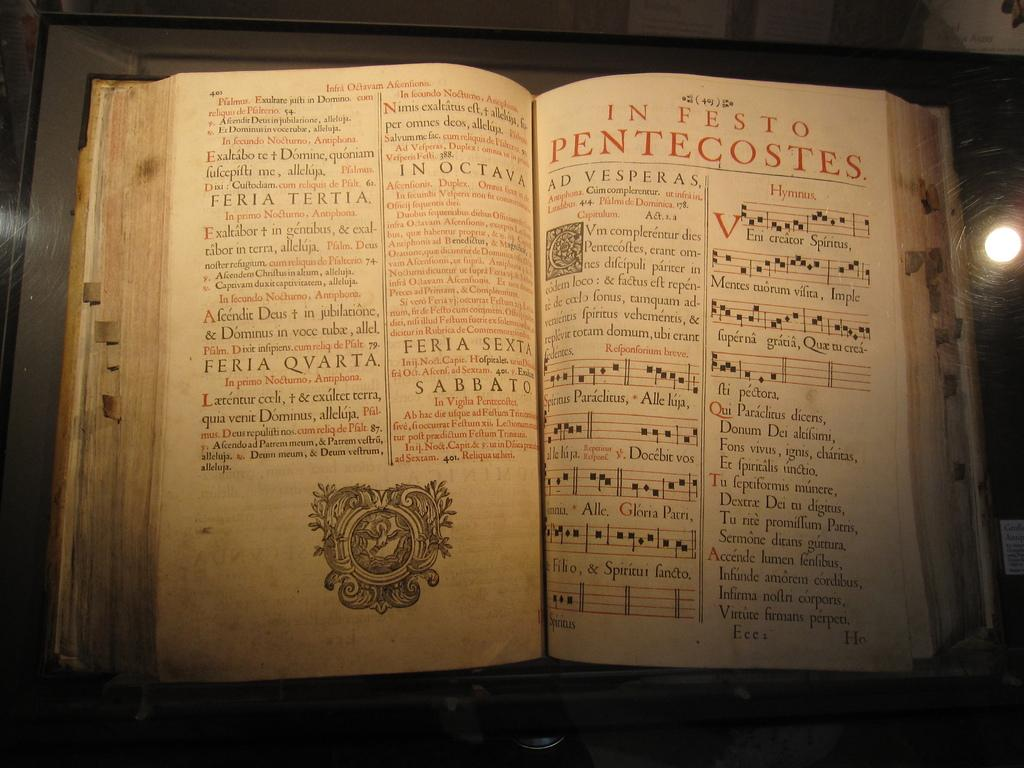Provide a one-sentence caption for the provided image. A large, old book open to a page that reads, "In Festo Pentecostes". 